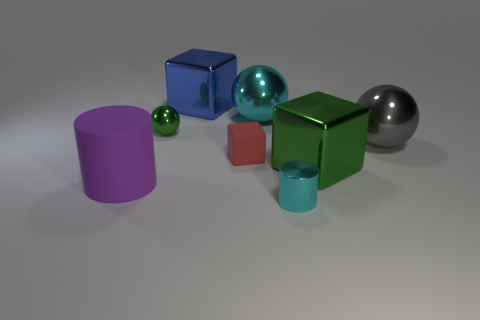What material is the cube that is behind the green shiny block and in front of the tiny green ball? The cube situated behind the green shiny block and in front of the tiny green ball appears to be made of a blue glass material, characterized by its transparency and reflections similar to those of glass objects. 